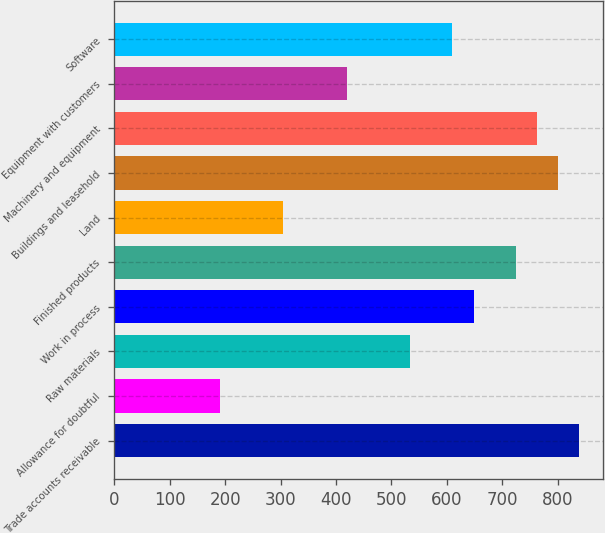<chart> <loc_0><loc_0><loc_500><loc_500><bar_chart><fcel>Trade accounts receivable<fcel>Allowance for doubtful<fcel>Raw materials<fcel>Work in process<fcel>Finished products<fcel>Land<fcel>Buildings and leasehold<fcel>Machinery and equipment<fcel>Equipment with customers<fcel>Software<nl><fcel>838.96<fcel>190.75<fcel>533.92<fcel>648.31<fcel>724.57<fcel>305.14<fcel>800.83<fcel>762.7<fcel>419.53<fcel>610.18<nl></chart> 